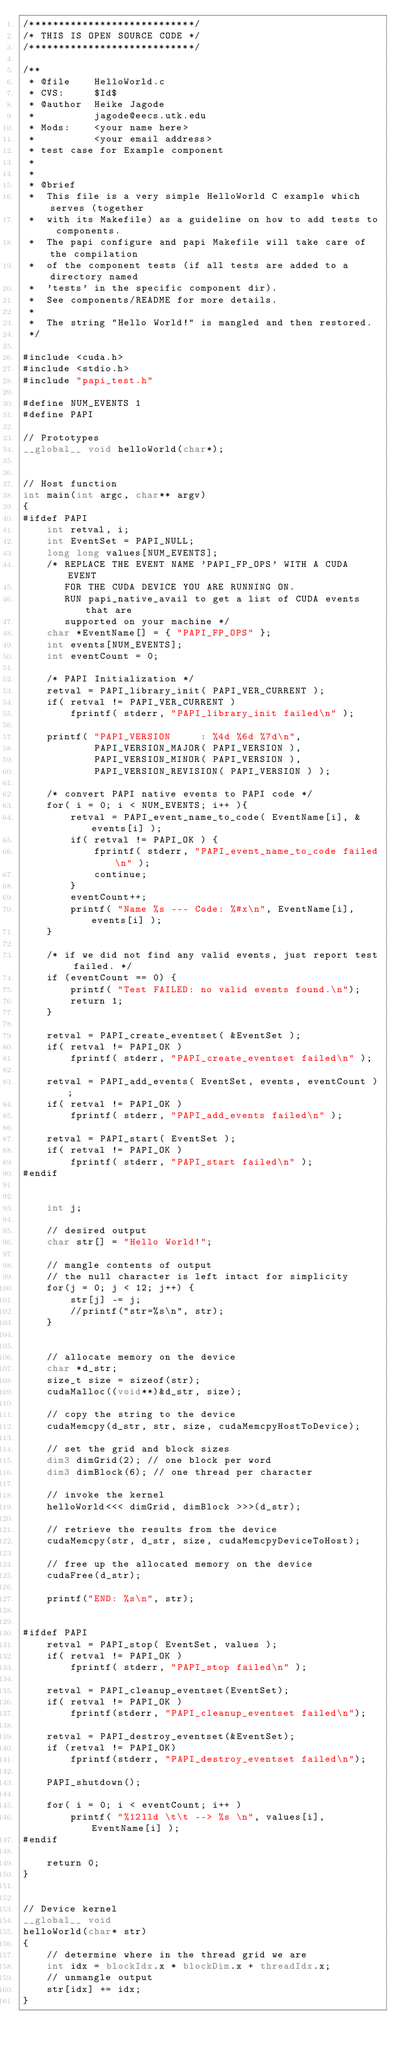<code> <loc_0><loc_0><loc_500><loc_500><_Cuda_>/****************************/
/* THIS IS OPEN SOURCE CODE */
/****************************/

/** 
 * @file    HelloWorld.c
 * CVS:     $Id$
 * @author  Heike Jagode
 *          jagode@eecs.utk.edu
 * Mods:	<your name here>
 *			<your email address>
 * test case for Example component 
 * 
 *
 * @brief
 *  This file is a very simple HelloWorld C example which serves (together
 *	with its Makefile) as a guideline on how to add tests to components.
 *  The papi configure and papi Makefile will take care of the compilation
 *	of the component tests (if all tests are added to a directory named
 *	'tests' in the specific component dir).
 *	See components/README for more details.
 *
 *	The string "Hello World!" is mangled and then restored.
 */

#include <cuda.h>
#include <stdio.h>
#include "papi_test.h"

#define NUM_EVENTS 1
#define PAPI

// Prototypes
__global__ void helloWorld(char*);


// Host function
int main(int argc, char** argv)
{
#ifdef PAPI
	int retval, i;
	int EventSet = PAPI_NULL;
	long long values[NUM_EVENTS];
	/* REPLACE THE EVENT NAME 'PAPI_FP_OPS' WITH A CUDA EVENT 
	   FOR THE CUDA DEVICE YOU ARE RUNNING ON.
	   RUN papi_native_avail to get a list of CUDA events that are 
	   supported on your machine */
    char *EventName[] = { "PAPI_FP_OPS" };
	int events[NUM_EVENTS];
	int eventCount = 0;
	
	/* PAPI Initialization */
	retval = PAPI_library_init( PAPI_VER_CURRENT );
	if( retval != PAPI_VER_CURRENT )
		fprintf( stderr, "PAPI_library_init failed\n" );
	
	printf( "PAPI_VERSION     : %4d %6d %7d\n",
			PAPI_VERSION_MAJOR( PAPI_VERSION ),
			PAPI_VERSION_MINOR( PAPI_VERSION ),
			PAPI_VERSION_REVISION( PAPI_VERSION ) );
	
	/* convert PAPI native events to PAPI code */
	for( i = 0; i < NUM_EVENTS; i++ ){
		retval = PAPI_event_name_to_code( EventName[i], &events[i] );
		if( retval != PAPI_OK ) {
			fprintf( stderr, "PAPI_event_name_to_code failed\n" );
			continue;
		}
		eventCount++;
		printf( "Name %s --- Code: %#x\n", EventName[i], events[i] );
	}

	/* if we did not find any valid events, just report test failed. */
	if (eventCount == 0) {
		printf( "Test FAILED: no valid events found.\n");
		return 1;
	}
	
	retval = PAPI_create_eventset( &EventSet );
	if( retval != PAPI_OK )
		fprintf( stderr, "PAPI_create_eventset failed\n" );
	
	retval = PAPI_add_events( EventSet, events, eventCount );
	if( retval != PAPI_OK )
		fprintf( stderr, "PAPI_add_events failed\n" );
	
	retval = PAPI_start( EventSet );
	if( retval != PAPI_OK )
		fprintf( stderr, "PAPI_start failed\n" );
#endif


	int j;
	
	// desired output
	char str[] = "Hello World!";

	// mangle contents of output
	// the null character is left intact for simplicity
	for(j = 0; j < 12; j++) {
		str[j] -= j;
		//printf("str=%s\n", str);
	}

	
	// allocate memory on the device
	char *d_str;
	size_t size = sizeof(str);
	cudaMalloc((void**)&d_str, size);
	
	// copy the string to the device
	cudaMemcpy(d_str, str, size, cudaMemcpyHostToDevice);
	
	// set the grid and block sizes
	dim3 dimGrid(2); // one block per word
	dim3 dimBlock(6); // one thread per character

	// invoke the kernel
	helloWorld<<< dimGrid, dimBlock >>>(d_str);

	// retrieve the results from the device
	cudaMemcpy(str, d_str, size, cudaMemcpyDeviceToHost);
	
	// free up the allocated memory on the device
	cudaFree(d_str);
	
	printf("END: %s\n", str);

	
#ifdef PAPI
	retval = PAPI_stop( EventSet, values );
	if( retval != PAPI_OK )
		fprintf( stderr, "PAPI_stop failed\n" );

	retval = PAPI_cleanup_eventset(EventSet);
	if( retval != PAPI_OK )
		fprintf(stderr, "PAPI_cleanup_eventset failed\n");

	retval = PAPI_destroy_eventset(&EventSet);
	if (retval != PAPI_OK)
		fprintf(stderr, "PAPI_destroy_eventset failed\n");

	PAPI_shutdown();

	for( i = 0; i < eventCount; i++ )
		printf( "%12lld \t\t --> %s \n", values[i], EventName[i] );
#endif

	return 0;
}


// Device kernel
__global__ void
helloWorld(char* str)
{
	// determine where in the thread grid we are
	int idx = blockIdx.x * blockDim.x + threadIdx.x;
	// unmangle output
	str[idx] += idx;
}

</code> 